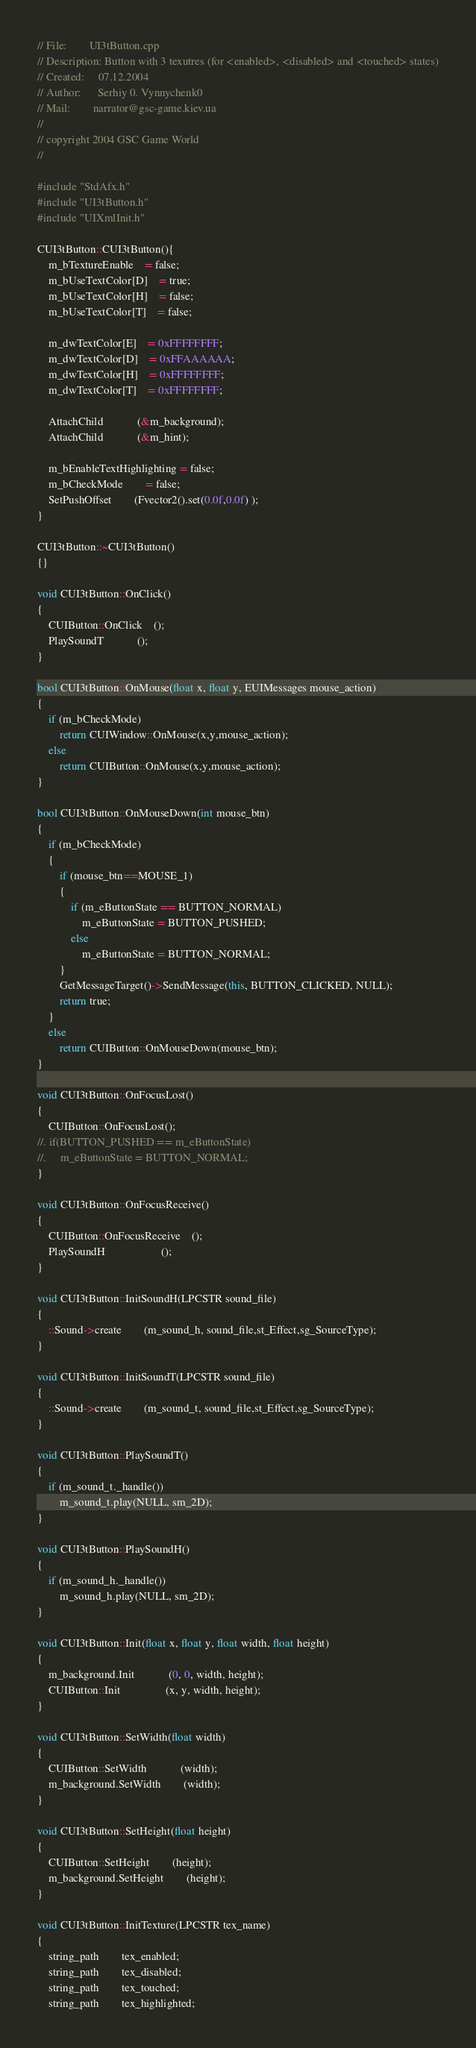Convert code to text. <code><loc_0><loc_0><loc_500><loc_500><_C++_>// File:        UI3tButton.cpp
// Description: Button with 3 texutres (for <enabled>, <disabled> and <touched> states)
// Created:     07.12.2004
// Author:      Serhiy 0. Vynnychenk0
// Mail:        narrator@gsc-game.kiev.ua
//
// copyright 2004 GSC Game World
//

#include "StdAfx.h"
#include "UI3tButton.h"
#include "UIXmlInit.h"

CUI3tButton::CUI3tButton(){
	m_bTextureEnable	= false;
	m_bUseTextColor[D]	= true;
	m_bUseTextColor[H]	= false;
	m_bUseTextColor[T]	= false;	

	m_dwTextColor[E] 	= 0xFFFFFFFF;
	m_dwTextColor[D] 	= 0xFFAAAAAA;
	m_dwTextColor[H] 	= 0xFFFFFFFF;
	m_dwTextColor[T] 	= 0xFFFFFFFF;

	AttachChild			(&m_background);
	AttachChild			(&m_hint);

	m_bEnableTextHighlighting = false;
	m_bCheckMode		= false;
	SetPushOffset		(Fvector2().set(0.0f,0.0f) );
}

CUI3tButton::~CUI3tButton()
{}

void CUI3tButton::OnClick()
{
    CUIButton::OnClick	();
    PlaySoundT			();
}

bool CUI3tButton::OnMouse(float x, float y, EUIMessages mouse_action)
{
	if (m_bCheckMode)
		return CUIWindow::OnMouse(x,y,mouse_action);
	else
		return CUIButton::OnMouse(x,y,mouse_action);
}

bool CUI3tButton::OnMouseDown(int mouse_btn)
{
	if (m_bCheckMode)
	{
		if (mouse_btn==MOUSE_1)
		{
			if (m_eButtonState == BUTTON_NORMAL)
				m_eButtonState = BUTTON_PUSHED;
			else
				m_eButtonState = BUTTON_NORMAL;
		}
		GetMessageTarget()->SendMessage(this, BUTTON_CLICKED, NULL);
		return true;
	}
	else
		return CUIButton::OnMouseDown(mouse_btn);
}

void CUI3tButton::OnFocusLost()
{
	CUIButton::OnFocusLost();
//.	if(BUTTON_PUSHED == m_eButtonState)
//.		m_eButtonState = BUTTON_NORMAL;
}

void CUI3tButton::OnFocusReceive()
{
	CUIButton::OnFocusReceive	();
	PlaySoundH					();
}

void CUI3tButton::InitSoundH(LPCSTR sound_file)
{
	::Sound->create		(m_sound_h, sound_file,st_Effect,sg_SourceType);
}

void CUI3tButton::InitSoundT(LPCSTR sound_file)
{
	::Sound->create		(m_sound_t, sound_file,st_Effect,sg_SourceType); 
}

void CUI3tButton::PlaySoundT()
{
	if (m_sound_t._handle())
        m_sound_t.play(NULL, sm_2D);
}

void CUI3tButton::PlaySoundH()
{
	if (m_sound_h._handle())
		m_sound_h.play(NULL, sm_2D);
}

void CUI3tButton::Init(float x, float y, float width, float height)
{
	m_background.Init			(0, 0, width, height);
    CUIButton::Init				(x, y, width, height);
}

void CUI3tButton::SetWidth(float width)
{
	CUIButton::SetWidth			(width);
	m_background.SetWidth		(width);
}

void CUI3tButton::SetHeight(float height)
{
	CUIButton::SetHeight		(height);
	m_background.SetHeight		(height);
}

void CUI3tButton::InitTexture(LPCSTR tex_name)
{
	string_path 		tex_enabled;
	string_path 		tex_disabled;
	string_path 		tex_touched;
	string_path 		tex_highlighted;
</code> 